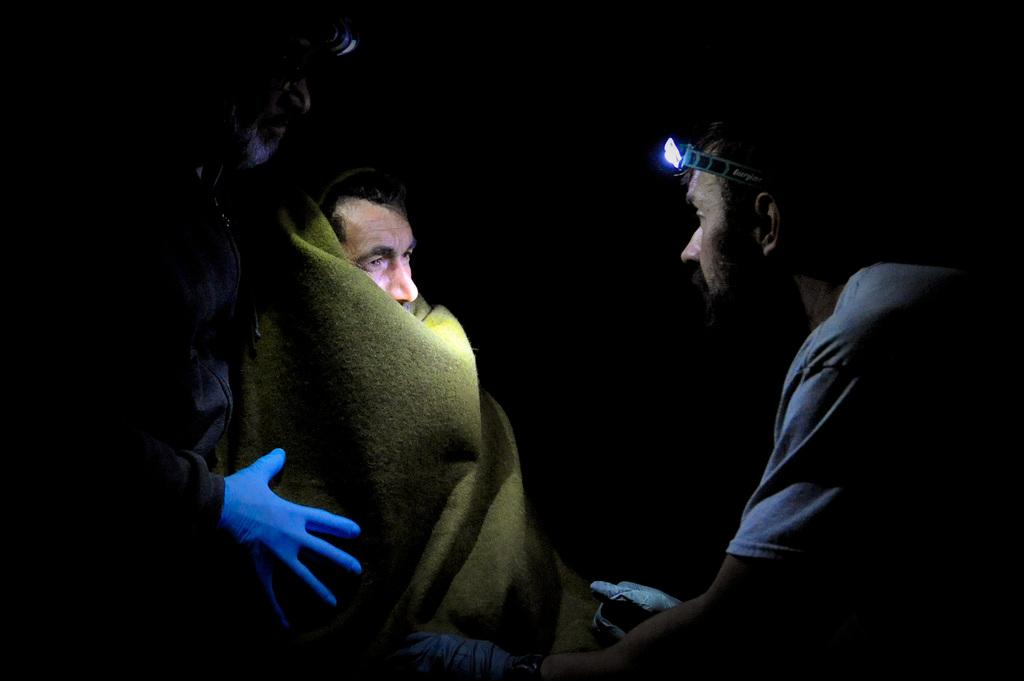How many people are in the image? There are three people in the image. What are the two people wearing on their heads? The two people are wearing headlight bands on their heads. What can be observed about the background of the image? The background of the image is dark. What type of poison can be seen in the image? There is no poison present in the image. How many tomatoes are visible in the image? There are no tomatoes present in the image. 